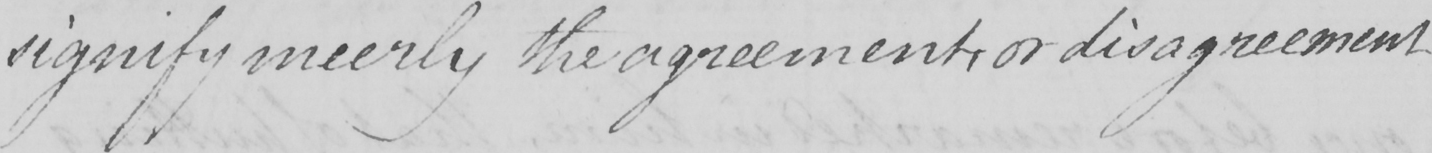Please transcribe the handwritten text in this image. signify meerly the agreement , or disagreement 